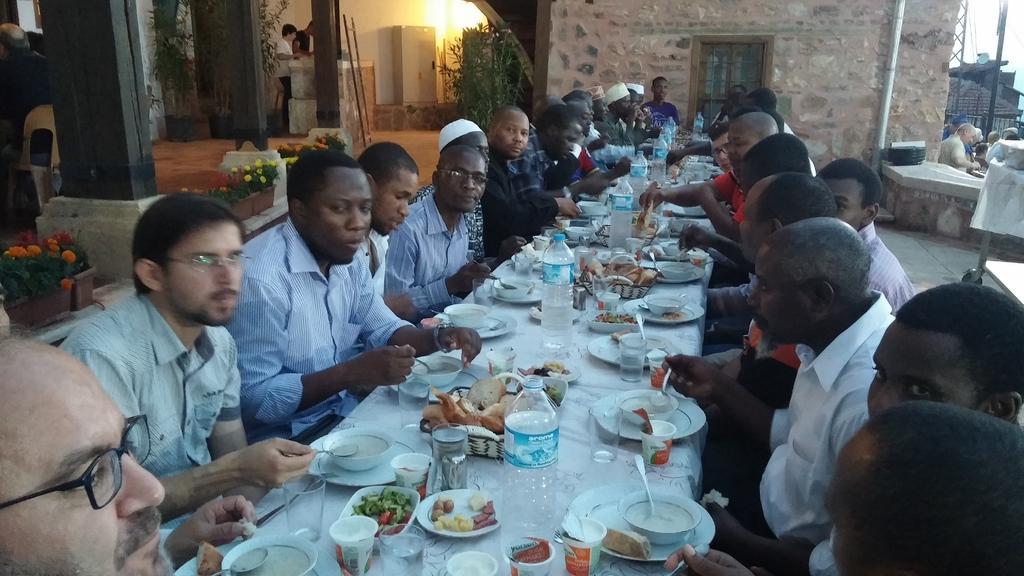How would you summarize this image in a sentence or two? This picture describes about group of people, few are seated, few are standing and few people wore spectacles, in front of them we can see few bottles, plates, bowls, spoons, food and other things on the table, on the right side of the image we can see flowers, in the background we can find few plants and lights, and also we can see a tower and a pipe. 